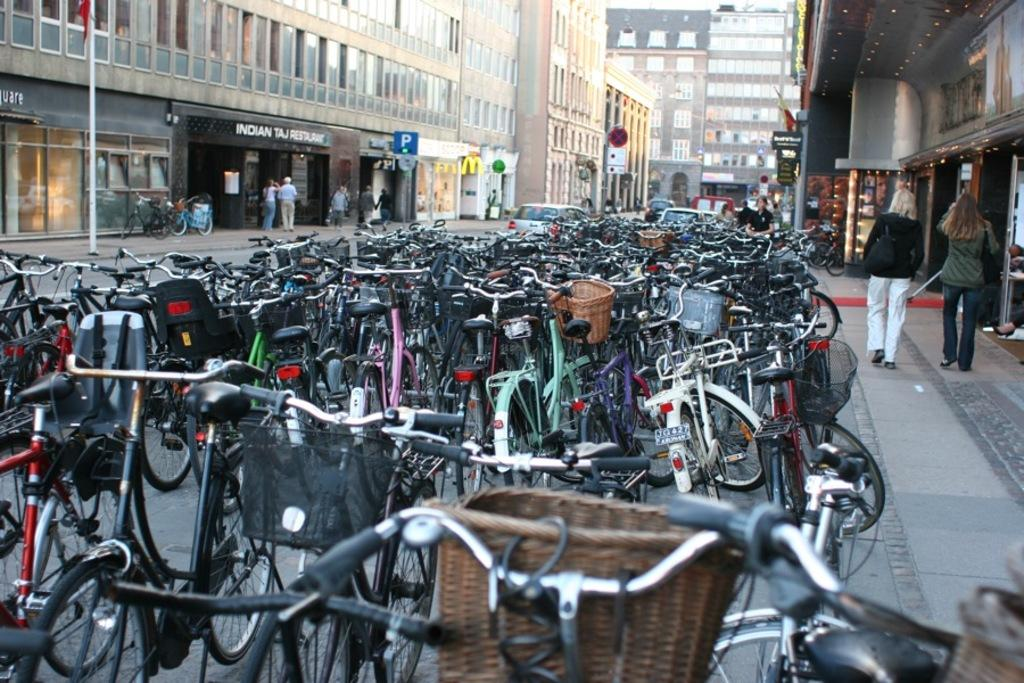What are the people in the image wearing? The persons in the image are wearing clothes. What can be seen in the top left corner of the image? There is a pole in the top left of the image. What type of vehicles are present in the image? There are cycles and cars in the image. What type of structures can be seen in the image? There are buildings in the image. What type of memory can be seen in the image? There is no memory present in the image. 